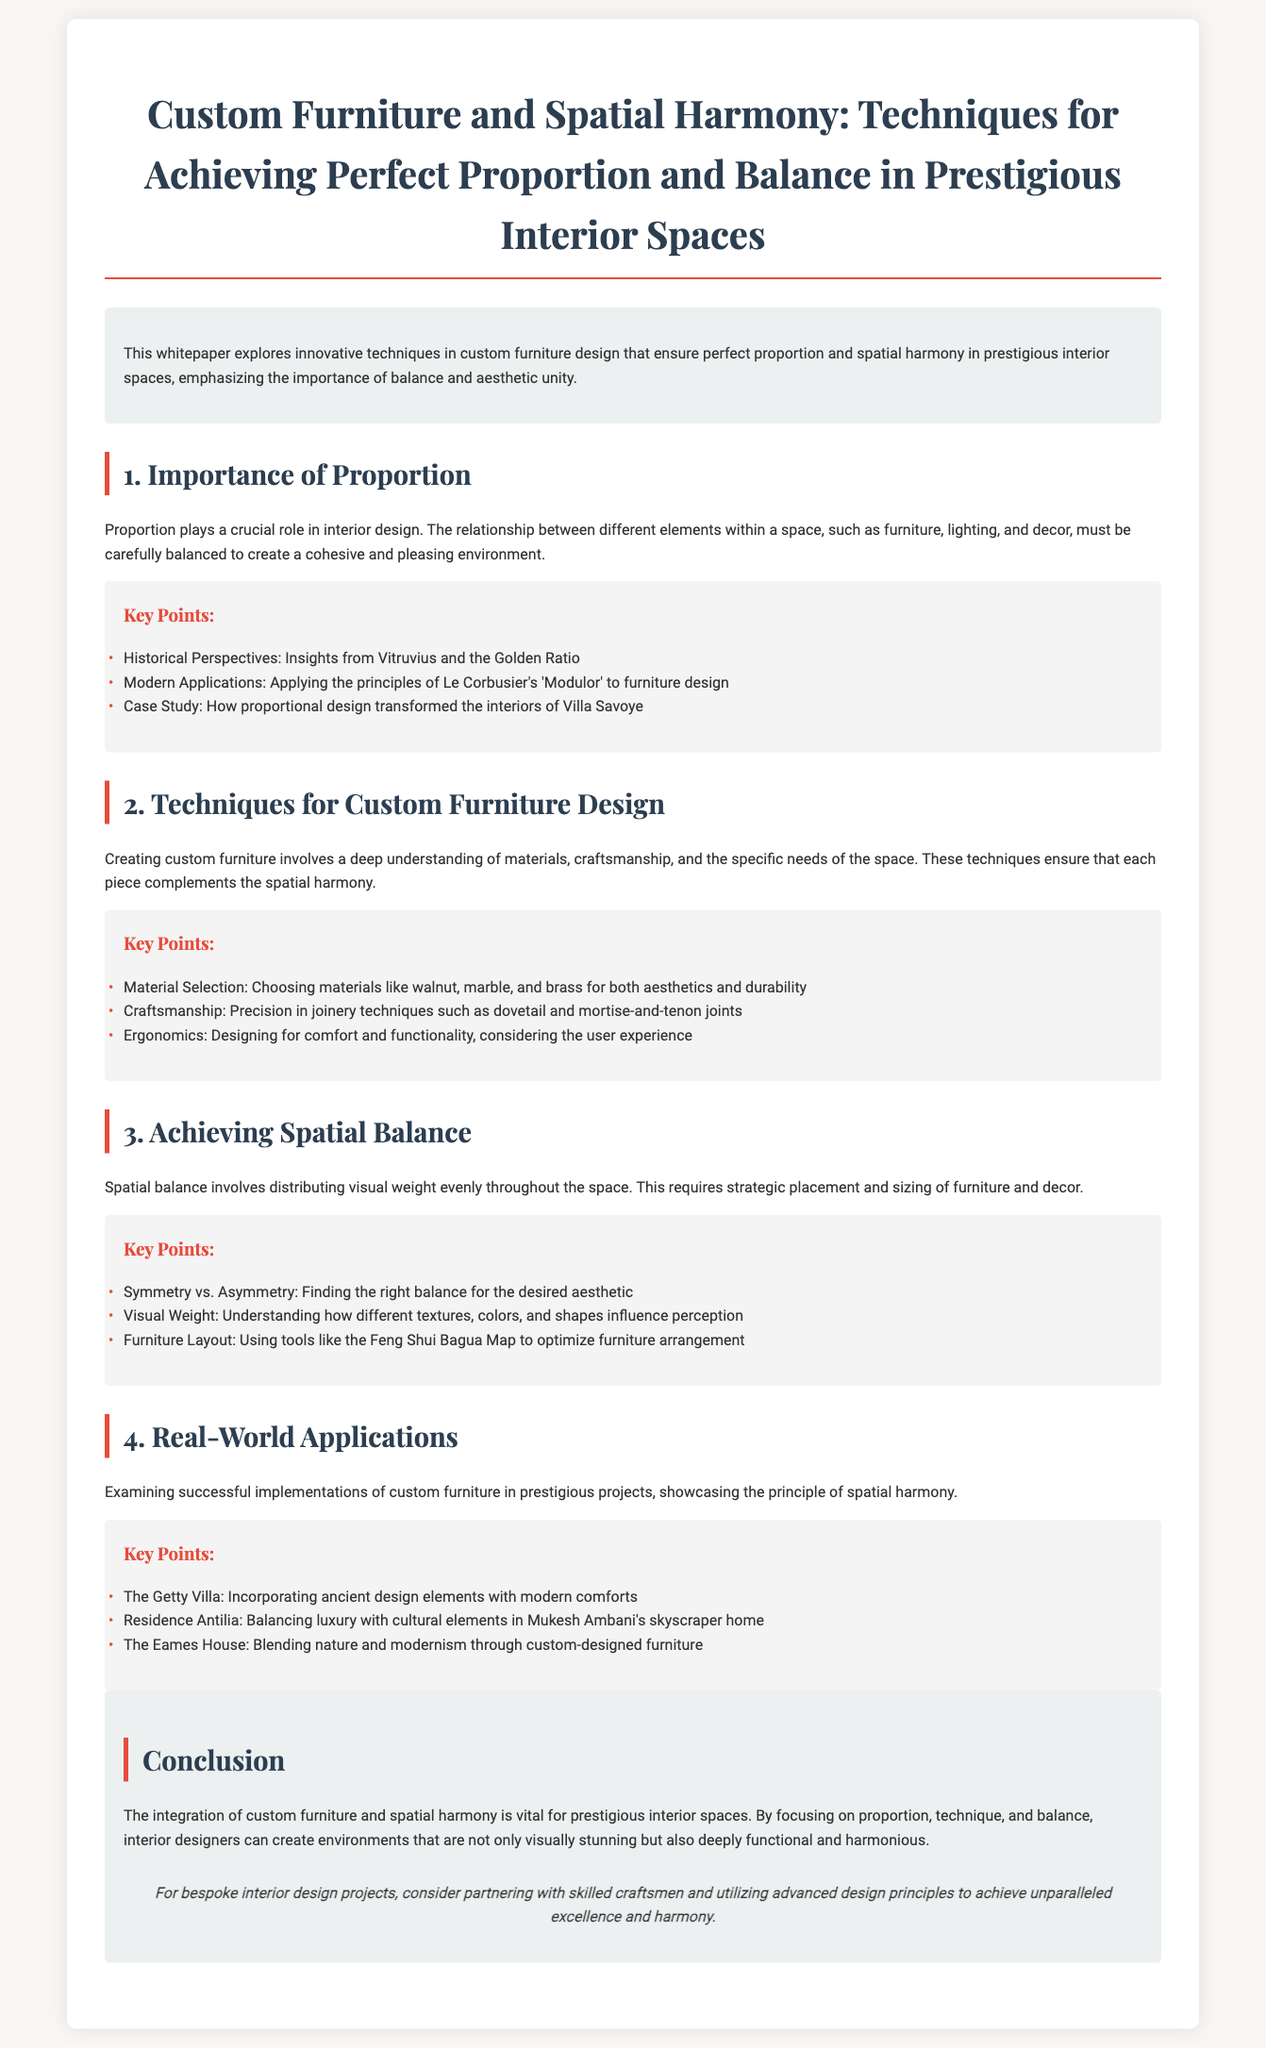What is the main topic of the whitepaper? The title of the whitepaper indicates it is about techniques for achieving perfect proportion and balance in interior spaces through custom furniture.
Answer: Custom Furniture and Spatial Harmony Who is the author of the concepts mentioned in the section about historical perspectives? Historical insights in the context of proportion are attributed to Vitruvius and the Golden Ratio.
Answer: Vitruvius What material is recommended for custom furniture for both aesthetics and durability? The document highlights the importance of selecting the right materials, including walnut, marble, and brass.
Answer: Walnut, marble, and brass Which design principle is associated with Le Corbusier? The principles of Le Corbusier's design philosophy are specifically mentioned in relation to furniture design within the document.
Answer: Modulor What are the two approaches to balance discussed? The document outlines symmetry and asymmetry as the two key approaches to achieving balance in interior design.
Answer: Symmetry vs. Asymmetry What high-profile residence is mentioned in the context of balancing luxury with cultural elements? The document discusses specific real-world applications, particularly in relation to Mukesh Ambani's skyscraper home.
Answer: Residence Antilia How does the whitepaper describe the integration of custom furniture? The conclusion of the whitepaper emphasizes that the integration of custom furniture is crucial for creating functional and harmonious interior spaces.
Answer: Vital for prestigious interior spaces What year is the document information up to? The content mentions that the data is trained on information up to a specific time, indicating a cutoff in relevance for current designs or trends.
Answer: October 2023 Which famous architectural project is noted for blending nature and modernism? The Eames House is cited as a successful project that exemplifies the blend of natural elements with modern furniture design principles.
Answer: The Eames House 